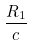Convert formula to latex. <formula><loc_0><loc_0><loc_500><loc_500>\frac { R _ { 1 } } { c }</formula> 